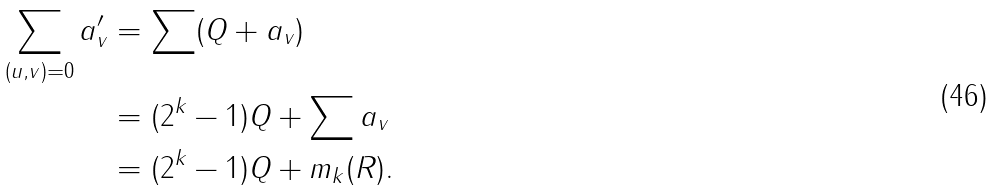<formula> <loc_0><loc_0><loc_500><loc_500>\sum _ { ( u , v ) = 0 } a ^ { \prime } _ { v } & = \sum ( Q + a _ { v } ) \\ & = ( 2 ^ { k } - 1 ) Q + \sum a _ { v } \\ & = ( 2 ^ { k } - 1 ) Q + m _ { k } ( R ) .</formula> 